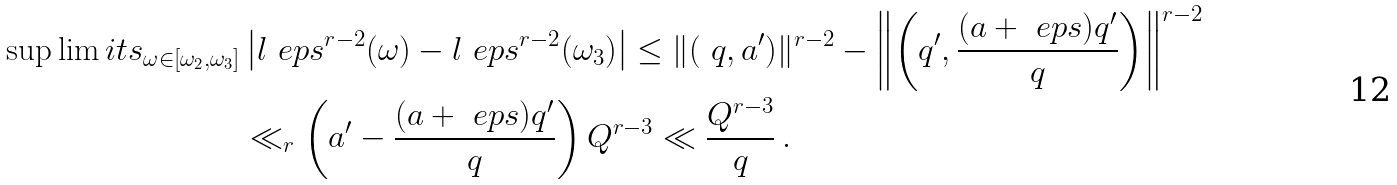<formula> <loc_0><loc_0><loc_500><loc_500>\sup \lim i t s _ { \omega \in [ \omega _ { 2 } , \omega _ { 3 } ] } & \left | l _ { \ } e p s ^ { r - 2 } ( \omega ) - l _ { \ } e p s ^ { r - 2 } ( \omega _ { 3 } ) \right | \leq \| ( \ q , a ^ { \prime } ) \| ^ { r - 2 } - \left \| \left ( q ^ { \prime } , \frac { ( a + \ e p s ) q ^ { \prime } } { q } \right ) \right \| ^ { r - 2 } \\ & \ll _ { r } \left ( a ^ { \prime } - \frac { ( a + \ e p s ) q ^ { \prime } } { q } \right ) Q ^ { r - 3 } \ll \frac { Q ^ { r - 3 } } { q } \, .</formula> 